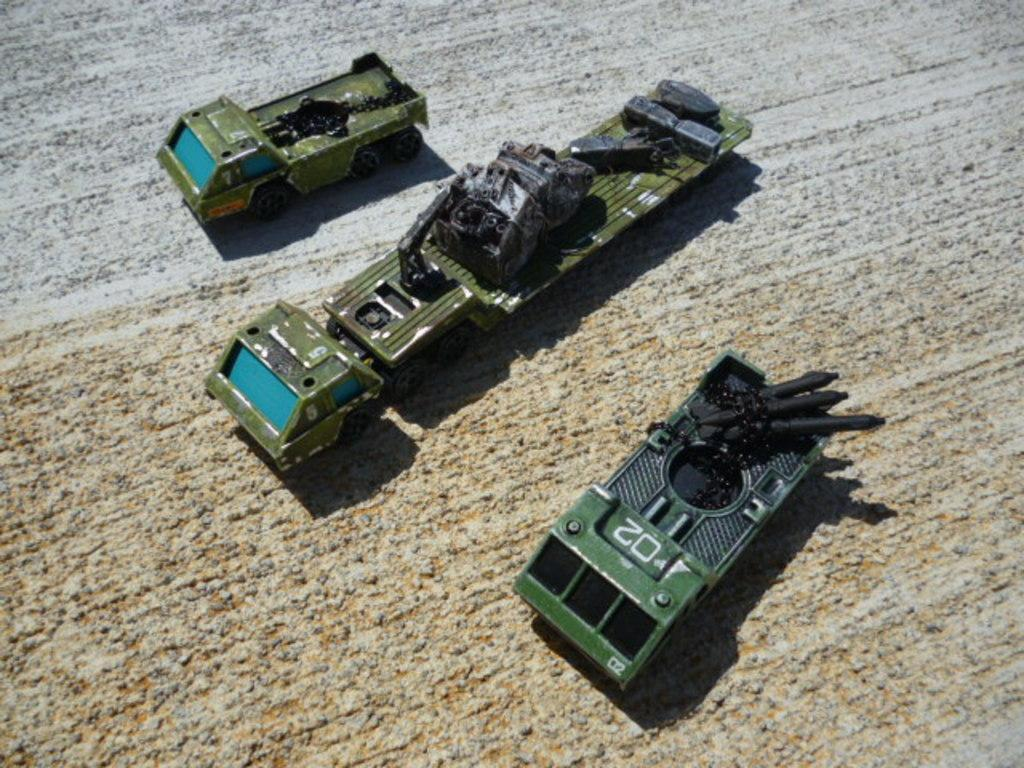How many vehicles can be seen in the image? There are three vehicles in the image. Where are the vehicles located? The vehicles are on the road. What colors are the vehicles? The vehicles are in green and blue colors. What colors are the road? The road is in ash and cream colors. What grade does the fact receive in the image? There are no grades or facts present in the image; it features vehicles on a road with specific colors. 